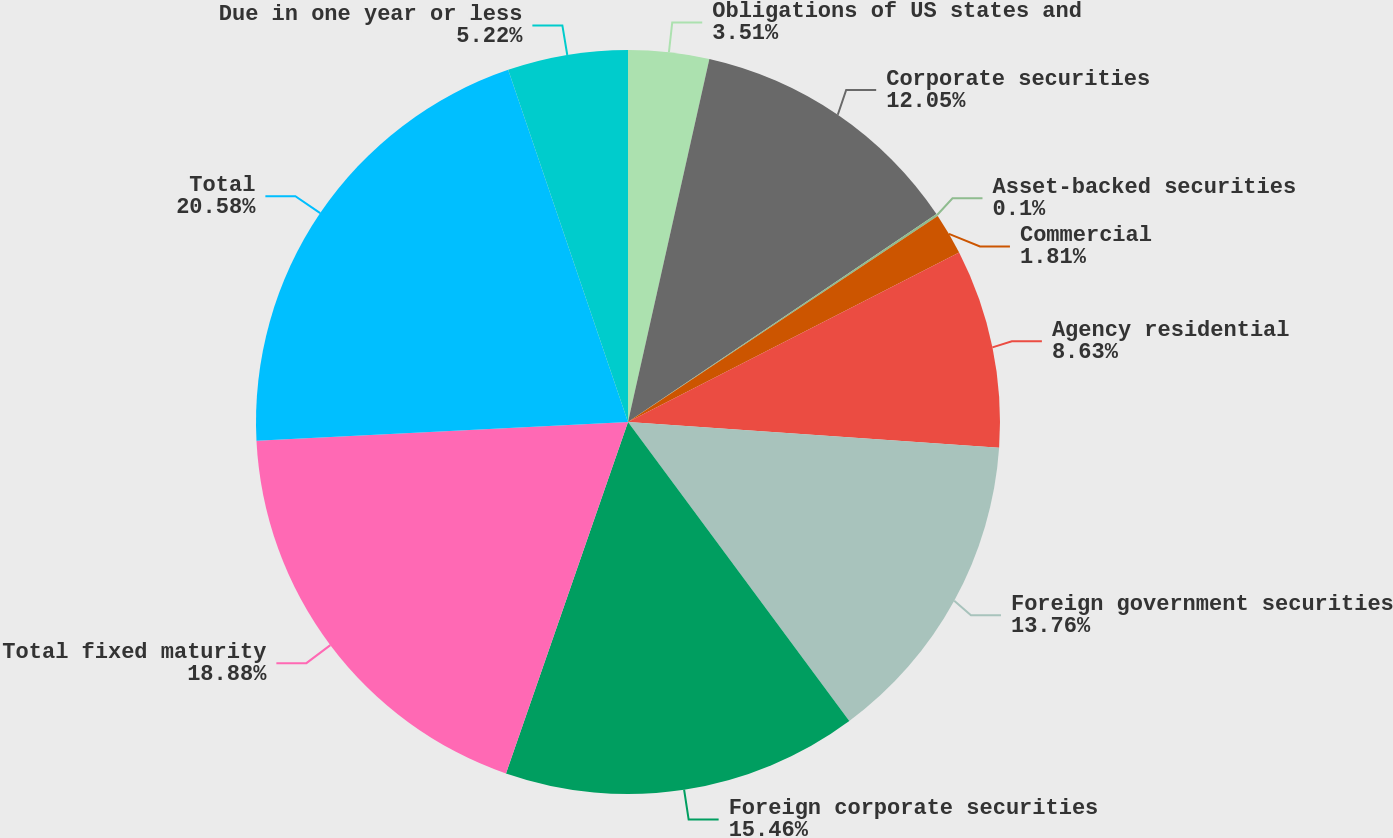Convert chart. <chart><loc_0><loc_0><loc_500><loc_500><pie_chart><fcel>Obligations of US states and<fcel>Corporate securities<fcel>Asset-backed securities<fcel>Commercial<fcel>Agency residential<fcel>Foreign government securities<fcel>Foreign corporate securities<fcel>Total fixed maturity<fcel>Total<fcel>Due in one year or less<nl><fcel>3.51%<fcel>12.05%<fcel>0.1%<fcel>1.81%<fcel>8.63%<fcel>13.76%<fcel>15.46%<fcel>18.88%<fcel>20.58%<fcel>5.22%<nl></chart> 